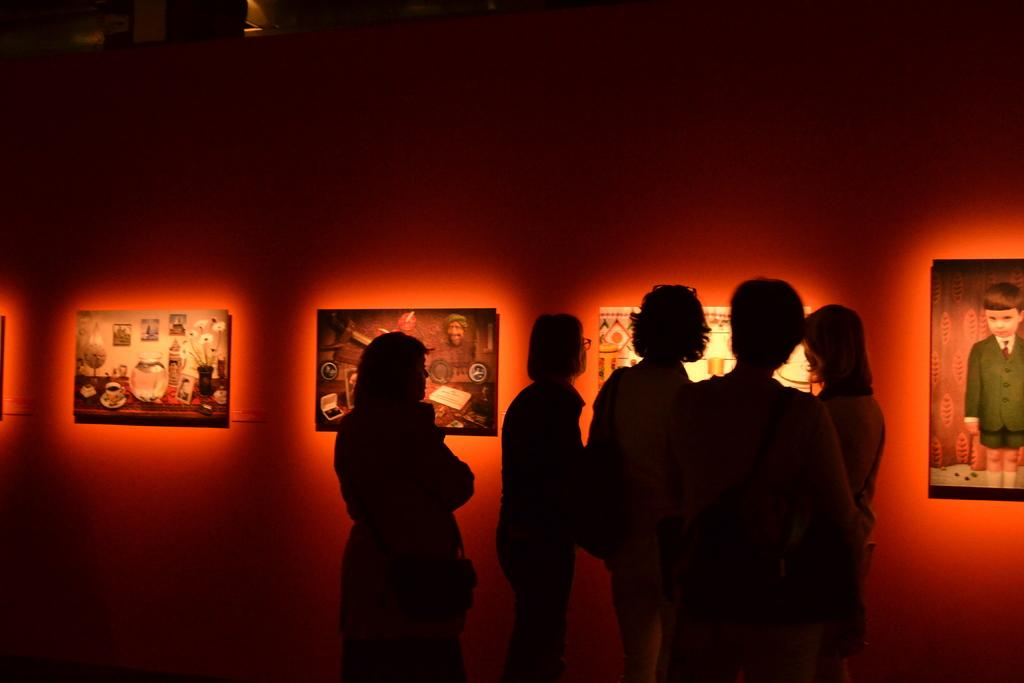Who or what is present in the image? There are people in the image. What can be seen in the background of the image? There is a wall in the image. What is depicted in the photo frames in the image? There are photo frames with lightning in the image. What type of animal can be seen stitching an order in the image? There is no animal present in the image, nor is there any stitching or order depicted. 